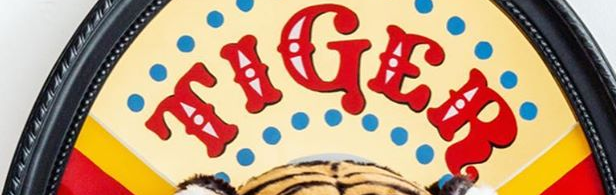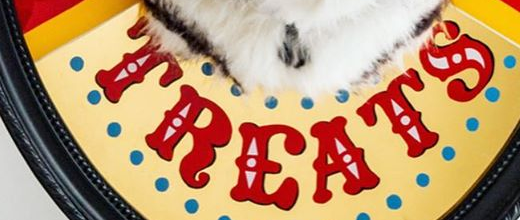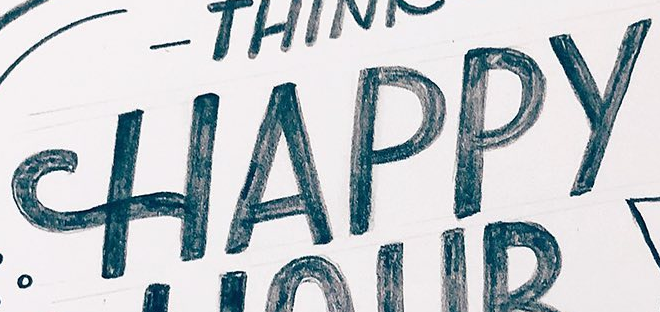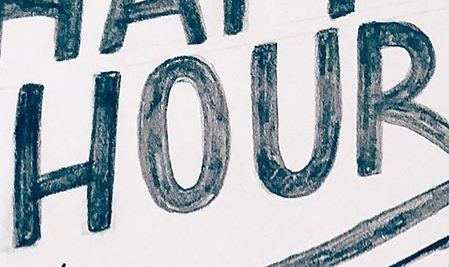What text is displayed in these images sequentially, separated by a semicolon? TIGER; TREATS; HAPPY; HOUR 